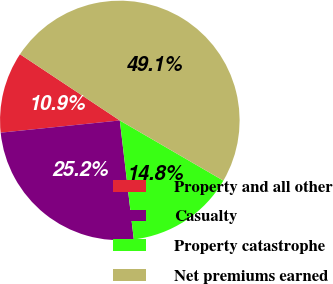Convert chart to OTSL. <chart><loc_0><loc_0><loc_500><loc_500><pie_chart><fcel>Property and all other<fcel>Casualty<fcel>Property catastrophe<fcel>Net premiums earned<nl><fcel>10.95%<fcel>25.24%<fcel>14.76%<fcel>49.06%<nl></chart> 